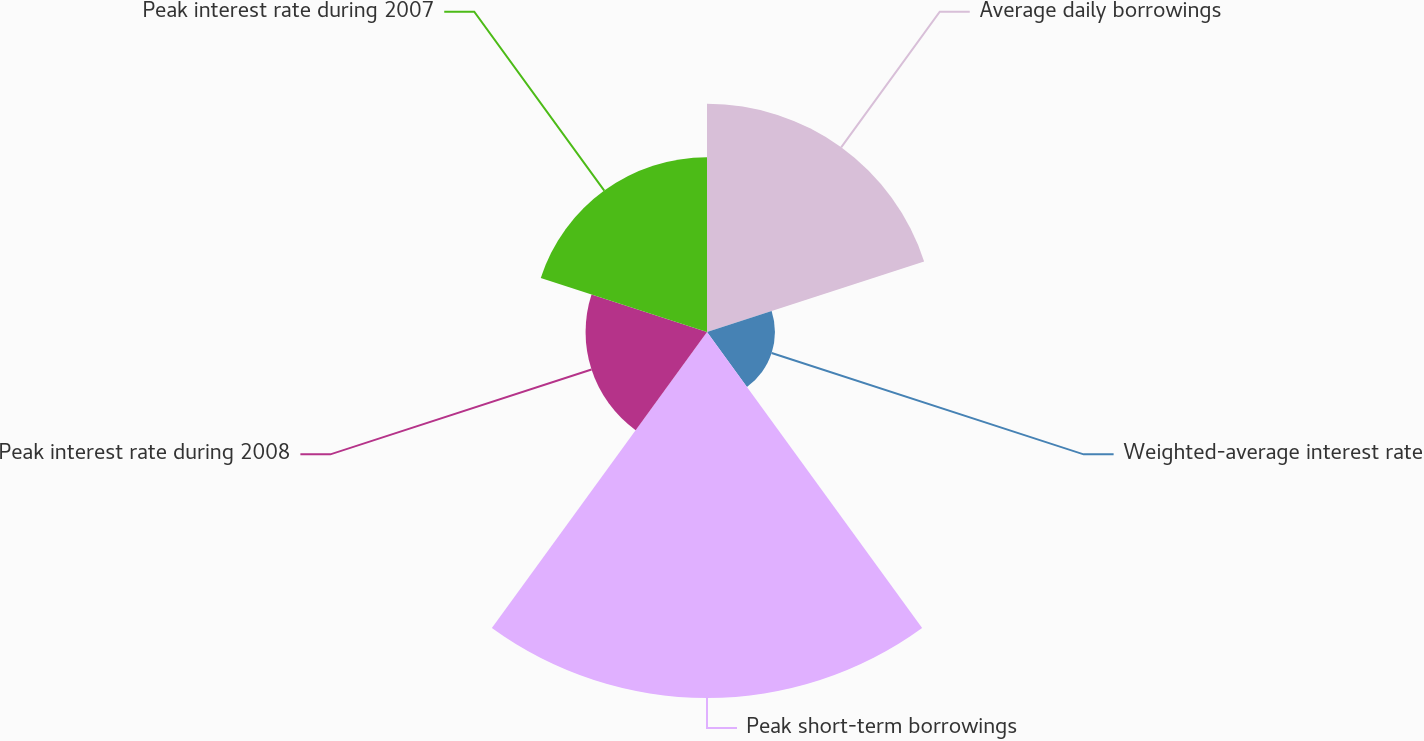Convert chart to OTSL. <chart><loc_0><loc_0><loc_500><loc_500><pie_chart><fcel>Average daily borrowings<fcel>Weighted-average interest rate<fcel>Peak short-term borrowings<fcel>Peak interest rate during 2008<fcel>Peak interest rate during 2007<nl><fcel>23.82%<fcel>7.09%<fcel>38.19%<fcel>12.67%<fcel>18.24%<nl></chart> 